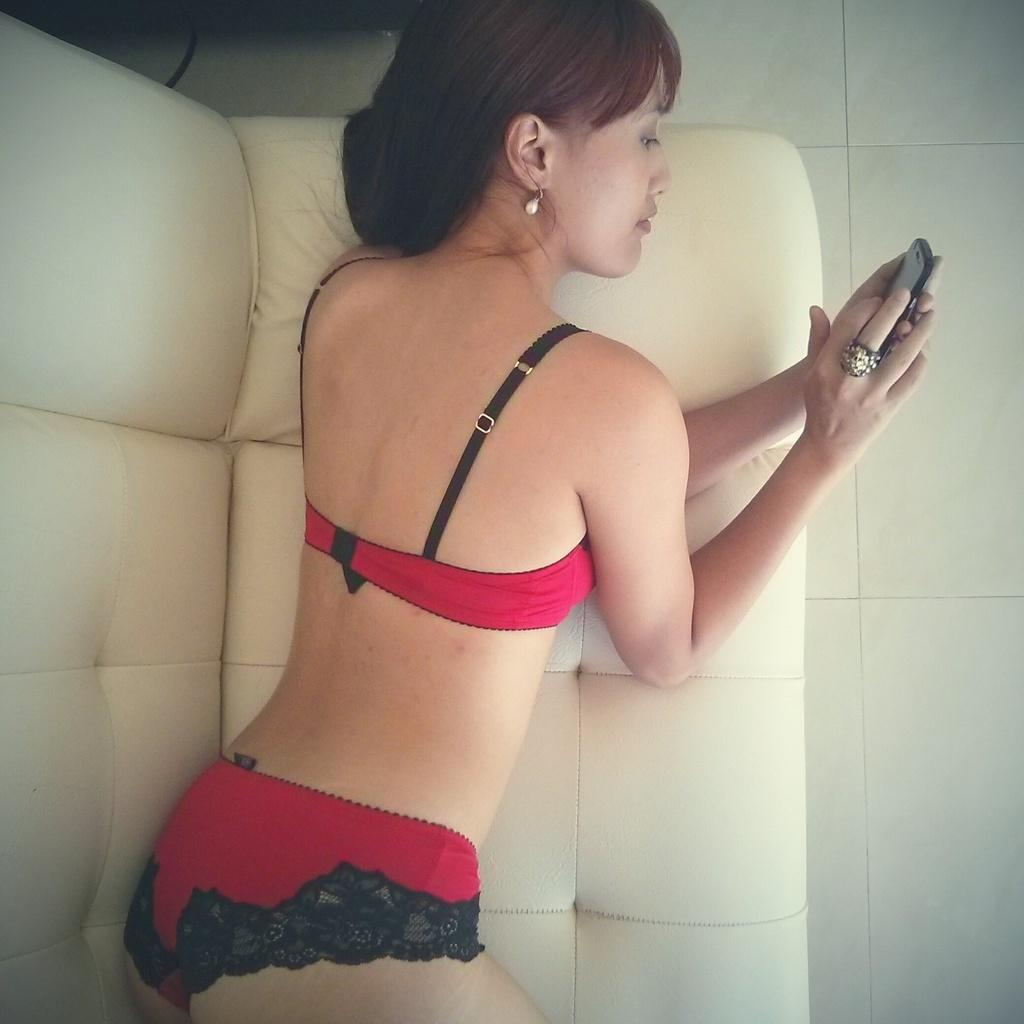Who is the main subject in the image? There is a woman in the image. What is the woman doing in the image? The woman is laying on a couch. What is the woman holding in her hands? The woman is holding a mobile in her hands. What is the woman's focus in the image? The woman is looking at the mobile. What can be seen on the right side of the image? The floor is visible on the right side of the image. What type of crook can be seen in the image? There is no crook present in the image. Can you touch the tin in the image? There is no tin present in the image to touch. 